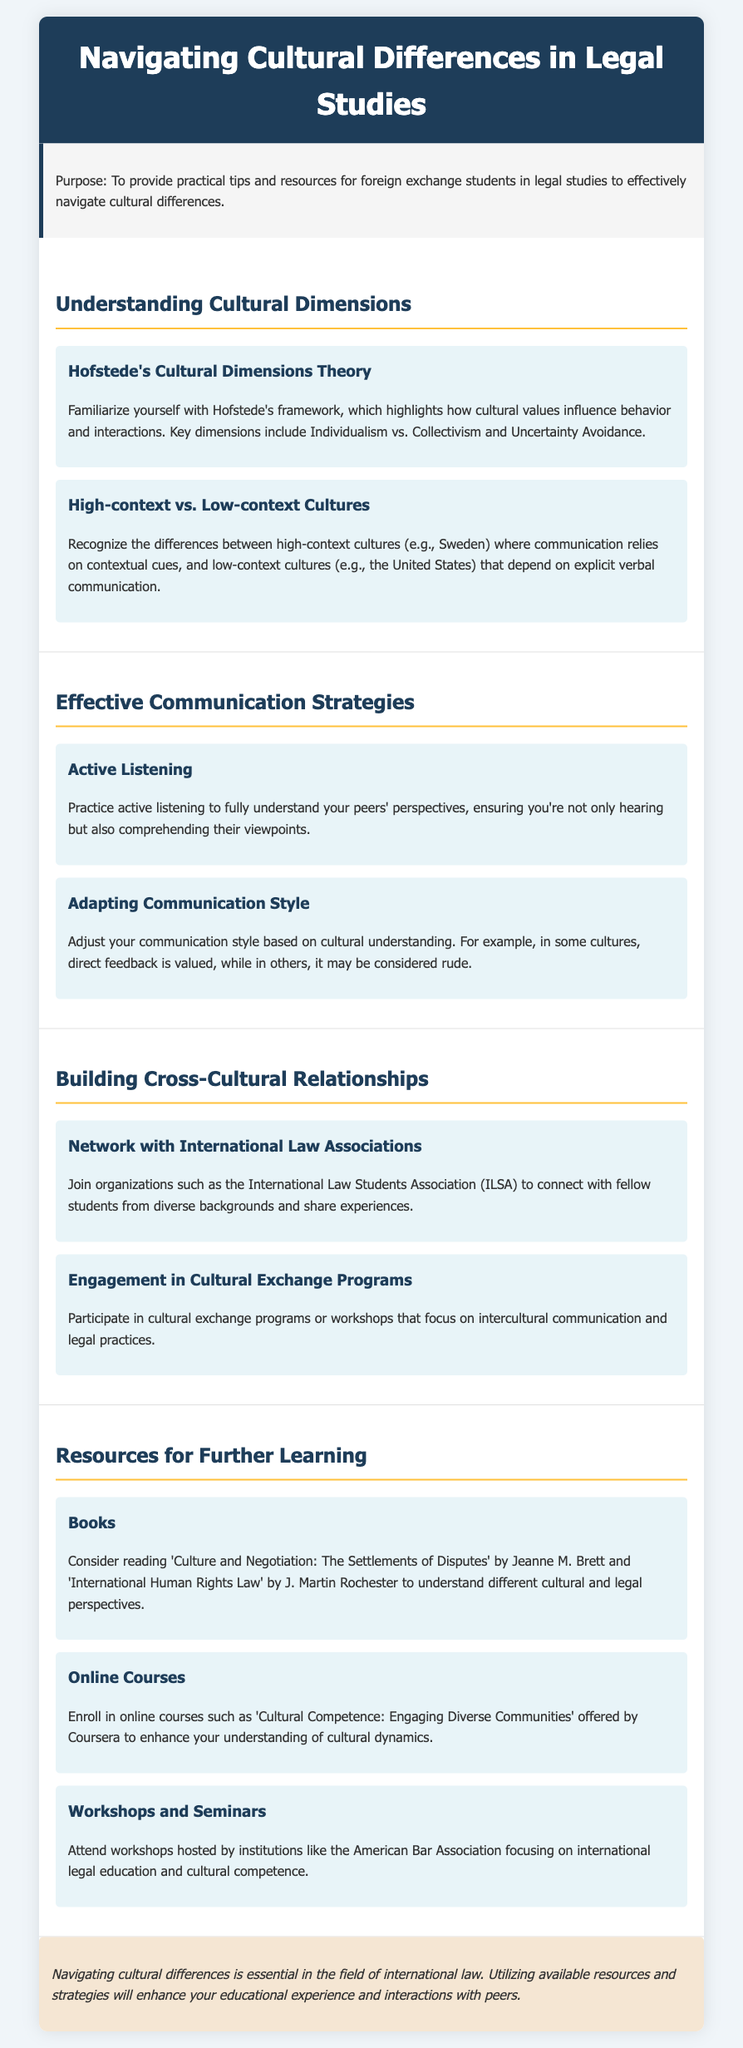what is the title of the document? The title of the document is indicated in the header, which states the main topic of discussion.
Answer: Navigating Cultural Differences in Legal Studies what framework is discussed under cultural dimensions? The document introduces a specific theoretical framework that focuses on cultural values and their impact on interactions.
Answer: Hofstede's Cultural Dimensions Theory which cultures rely on contextual cues according to the document? The text mentions specific types of cultures regarding their communication style.
Answer: High-context cultures what is one strategy mentioned for effective communication? The document outlines particular methods to enhance understanding among individuals from different cultures.
Answer: Active Listening what organization is suggested for networking? The document provides a name of an association for connecting with peers in the field of law.
Answer: International Law Students Association (ILSA) which online course platform is mentioned? The document refers to a specific platform that offers courses related to cultural competence.
Answer: Coursera how many books are listed under resources for further learning? The section lists several categories of resources, but the focus is on a specific number of books.
Answer: Two what type of events does the document encourage attendance at for cultural learning? The document suggests participation in specific types of educational experiences relevant to cultural understanding.
Answer: Workshops and Seminars what is the closing sentiment of the document? The final statement conveys the importance of the topic discussed throughout the document.
Answer: Essential in the field of international law 